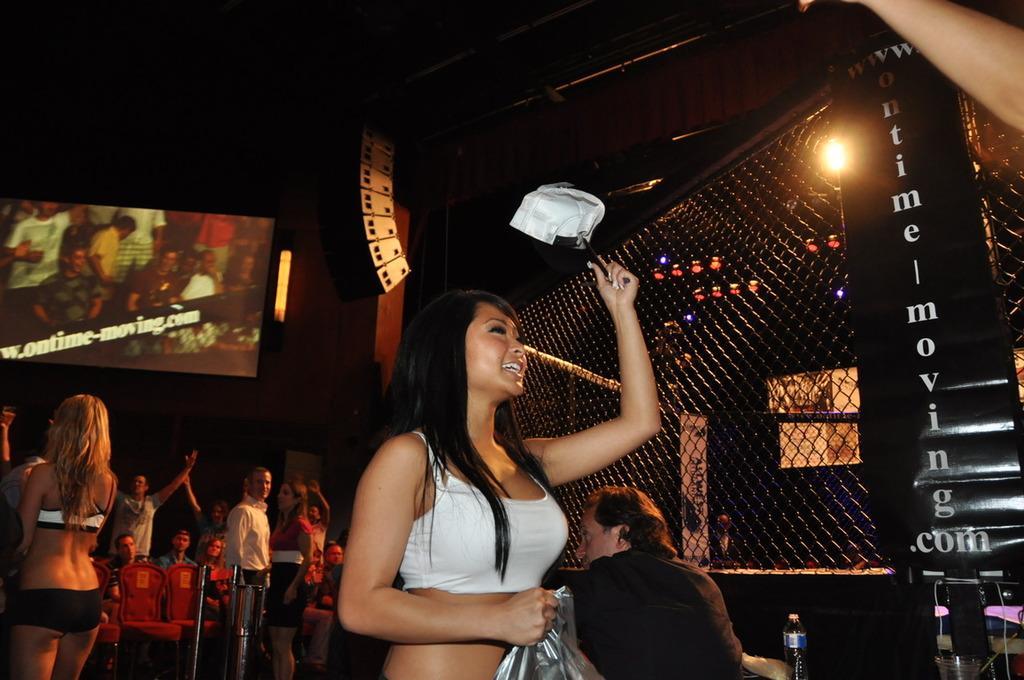Please provide a concise description of this image. In the image there is a woman standing in the middle, behind her there are many people standing and sitting all over place and above there is a screen, this seems to be clicked in a bar. 